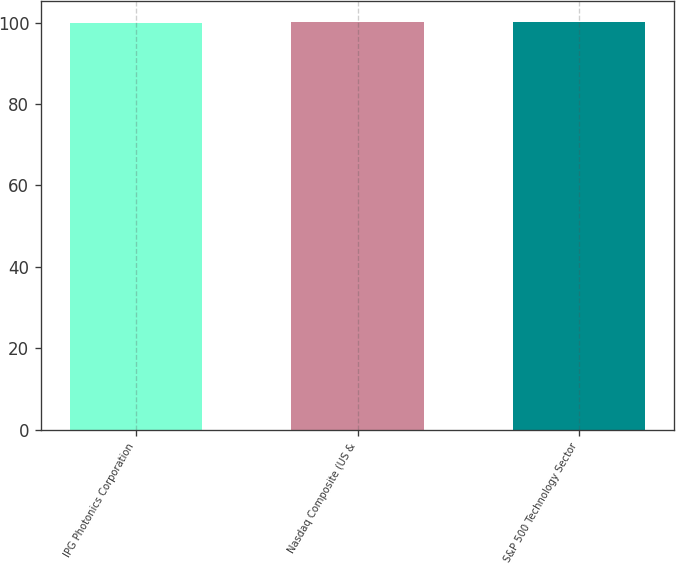Convert chart. <chart><loc_0><loc_0><loc_500><loc_500><bar_chart><fcel>IPG Photonics Corporation<fcel>Nasdaq Composite (US &<fcel>S&P 500 Technology Sector<nl><fcel>100<fcel>100.1<fcel>100.2<nl></chart> 